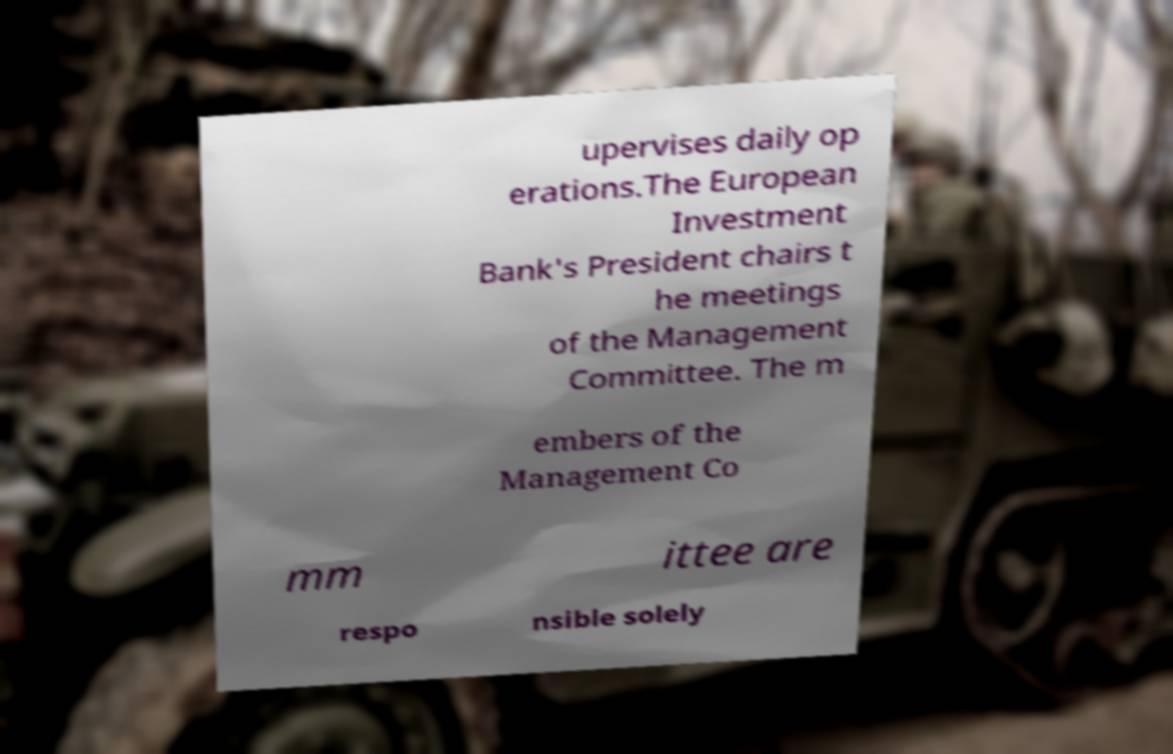I need the written content from this picture converted into text. Can you do that? upervises daily op erations.The European Investment Bank's President chairs t he meetings of the Management Committee. The m embers of the Management Co mm ittee are respo nsible solely 